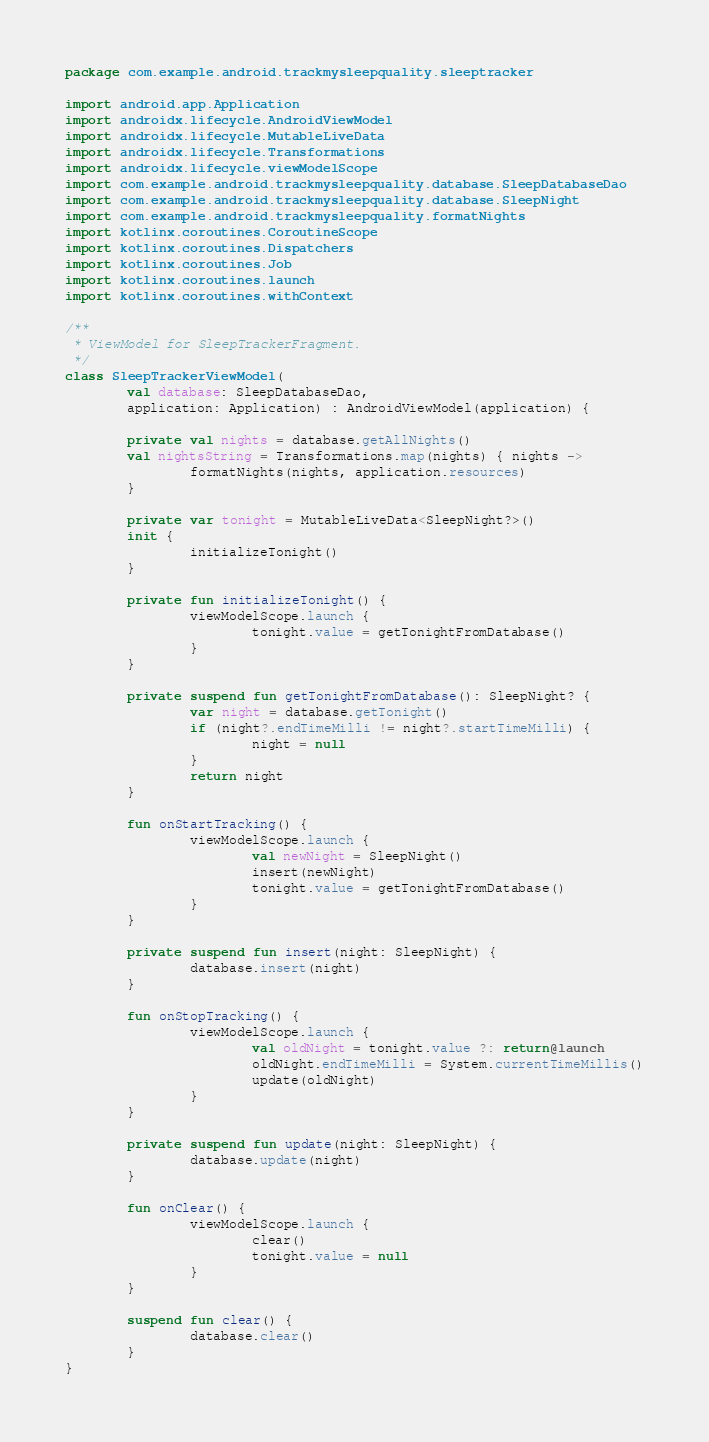Convert code to text. <code><loc_0><loc_0><loc_500><loc_500><_Kotlin_>package com.example.android.trackmysleepquality.sleeptracker

import android.app.Application
import androidx.lifecycle.AndroidViewModel
import androidx.lifecycle.MutableLiveData
import androidx.lifecycle.Transformations
import androidx.lifecycle.viewModelScope
import com.example.android.trackmysleepquality.database.SleepDatabaseDao
import com.example.android.trackmysleepquality.database.SleepNight
import com.example.android.trackmysleepquality.formatNights
import kotlinx.coroutines.CoroutineScope
import kotlinx.coroutines.Dispatchers
import kotlinx.coroutines.Job
import kotlinx.coroutines.launch
import kotlinx.coroutines.withContext

/**
 * ViewModel for SleepTrackerFragment.
 */
class SleepTrackerViewModel(
        val database: SleepDatabaseDao,
        application: Application) : AndroidViewModel(application) {

        private val nights = database.getAllNights()
        val nightsString = Transformations.map(nights) { nights ->
                formatNights(nights, application.resources)
        }

        private var tonight = MutableLiveData<SleepNight?>()
        init {
                initializeTonight()
        }

        private fun initializeTonight() {
                viewModelScope.launch {
                        tonight.value = getTonightFromDatabase()
                }
        }

        private suspend fun getTonightFromDatabase(): SleepNight? {
                var night = database.getTonight()
                if (night?.endTimeMilli != night?.startTimeMilli) {
                        night = null
                }
                return night
        }

        fun onStartTracking() {
                viewModelScope.launch {
                        val newNight = SleepNight()
                        insert(newNight)
                        tonight.value = getTonightFromDatabase()
                }
        }

        private suspend fun insert(night: SleepNight) {
                database.insert(night)
        }

        fun onStopTracking() {
                viewModelScope.launch {
                        val oldNight = tonight.value ?: return@launch
                        oldNight.endTimeMilli = System.currentTimeMillis()
                        update(oldNight)
                }
        }

        private suspend fun update(night: SleepNight) {
                database.update(night)
        }

        fun onClear() {
                viewModelScope.launch {
                        clear()
                        tonight.value = null
                }
        }

        suspend fun clear() {
                database.clear()
        }
}
</code> 